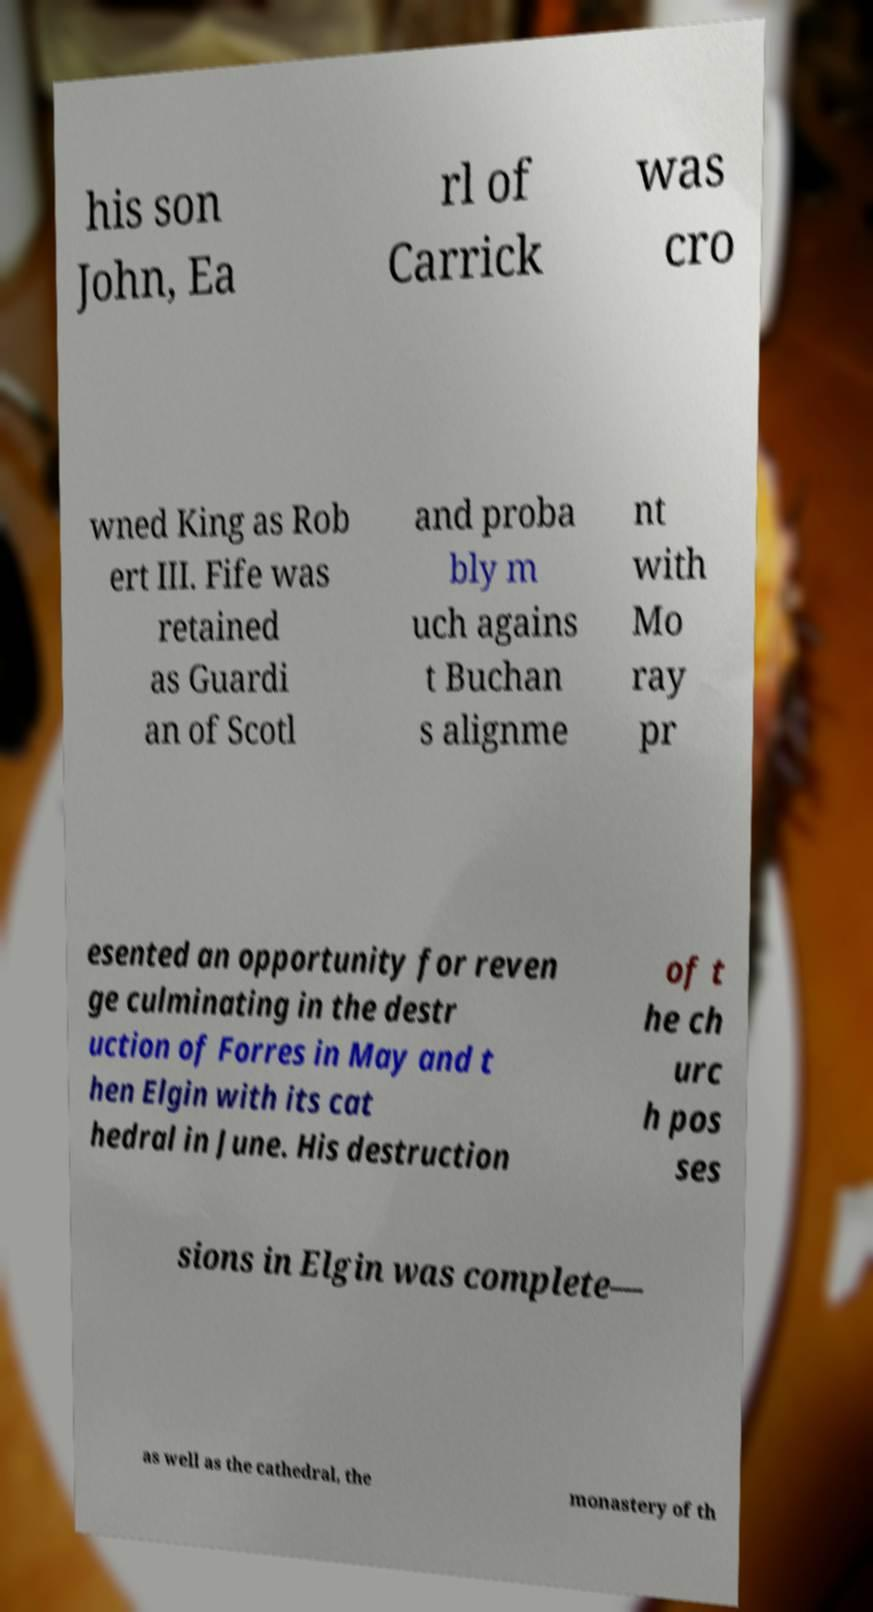Can you accurately transcribe the text from the provided image for me? his son John, Ea rl of Carrick was cro wned King as Rob ert III. Fife was retained as Guardi an of Scotl and proba bly m uch agains t Buchan s alignme nt with Mo ray pr esented an opportunity for reven ge culminating in the destr uction of Forres in May and t hen Elgin with its cat hedral in June. His destruction of t he ch urc h pos ses sions in Elgin was complete— as well as the cathedral, the monastery of th 